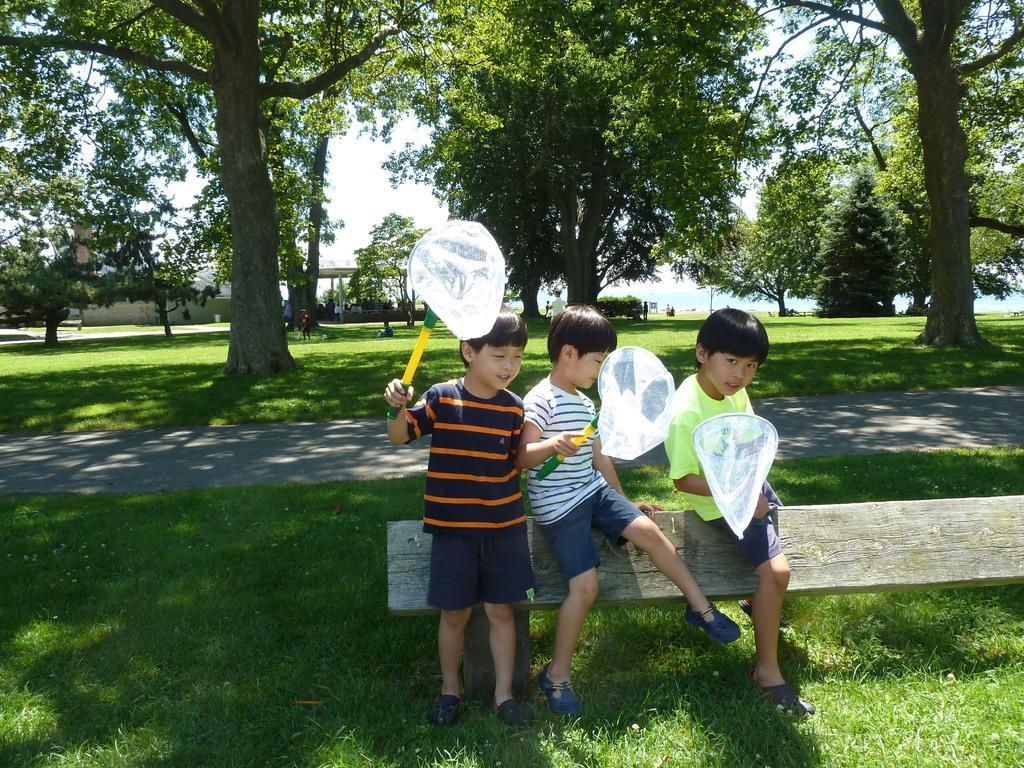Describe this image in one or two sentences. In this picture there are group of people, one is sitting and holding the object and two are standing and holding the object. At the back there are group of people and there is a building and there are trees and poles. At the top there is sky. At the bottom there is a road and there is grass. 